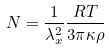<formula> <loc_0><loc_0><loc_500><loc_500>N = \frac { 1 } { \lambda _ { x } ^ { 2 } } \frac { R T } { 3 \pi \kappa \rho }</formula> 